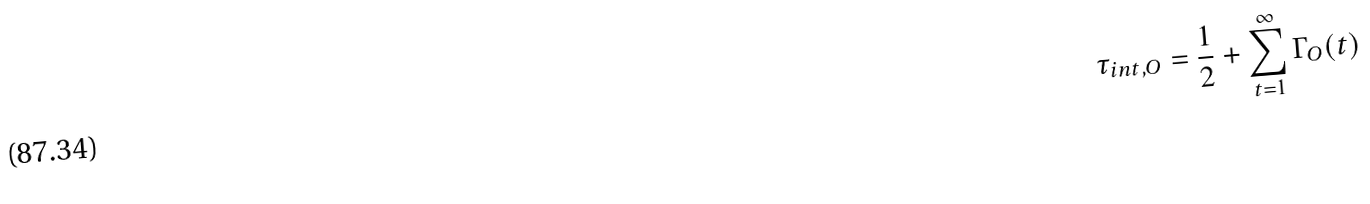<formula> <loc_0><loc_0><loc_500><loc_500>\tau _ { i n t , O } = \frac { 1 } { 2 } + \sum _ { t = 1 } ^ { \infty } \Gamma _ { O } ( t )</formula> 